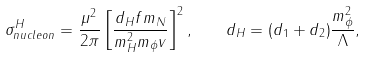<formula> <loc_0><loc_0><loc_500><loc_500>\sigma _ { n u c l e o n } ^ { H } = \frac { \mu ^ { 2 } } { 2 \pi } \left [ \frac { d _ { H } f m _ { N } } { m ^ { 2 } _ { H } m _ { \phi } v } \right ] ^ { 2 } , \quad d _ { H } = ( d _ { 1 } + d _ { 2 } ) \frac { m _ { \phi } ^ { 2 } } { \Lambda } ,</formula> 